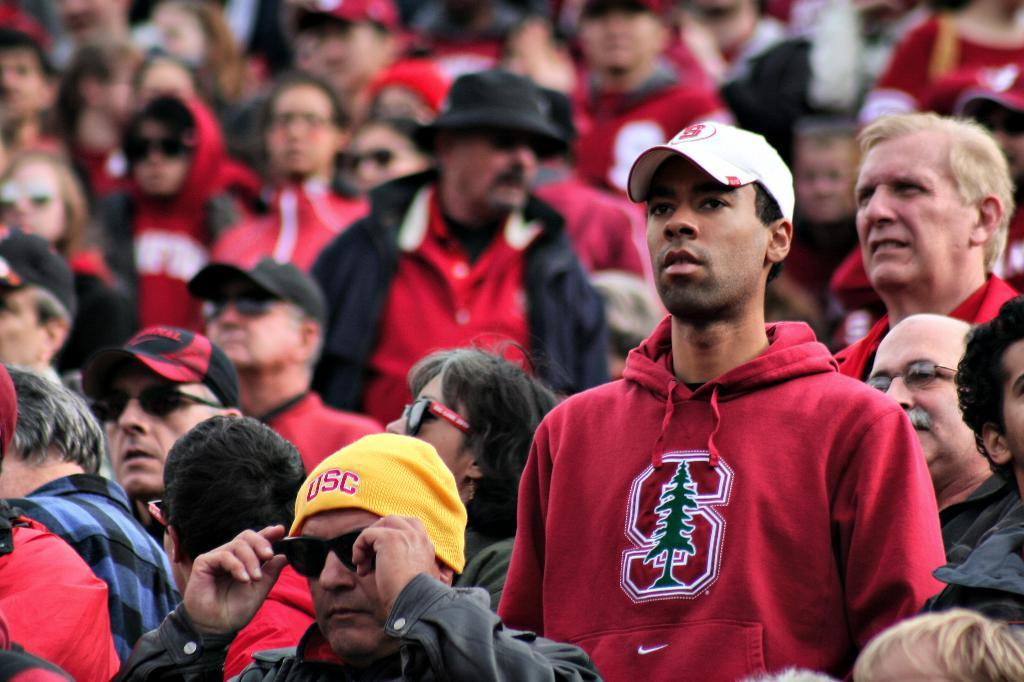How many individuals are present in the image? There are many people in the image. What are the people in the image doing? The people are standing. What type of station can be seen in the image? There is no station present in the image; it features many people standing. How does the shade affect the people in the image? There is no mention of shade in the image, as it only states that there are many people standing. 